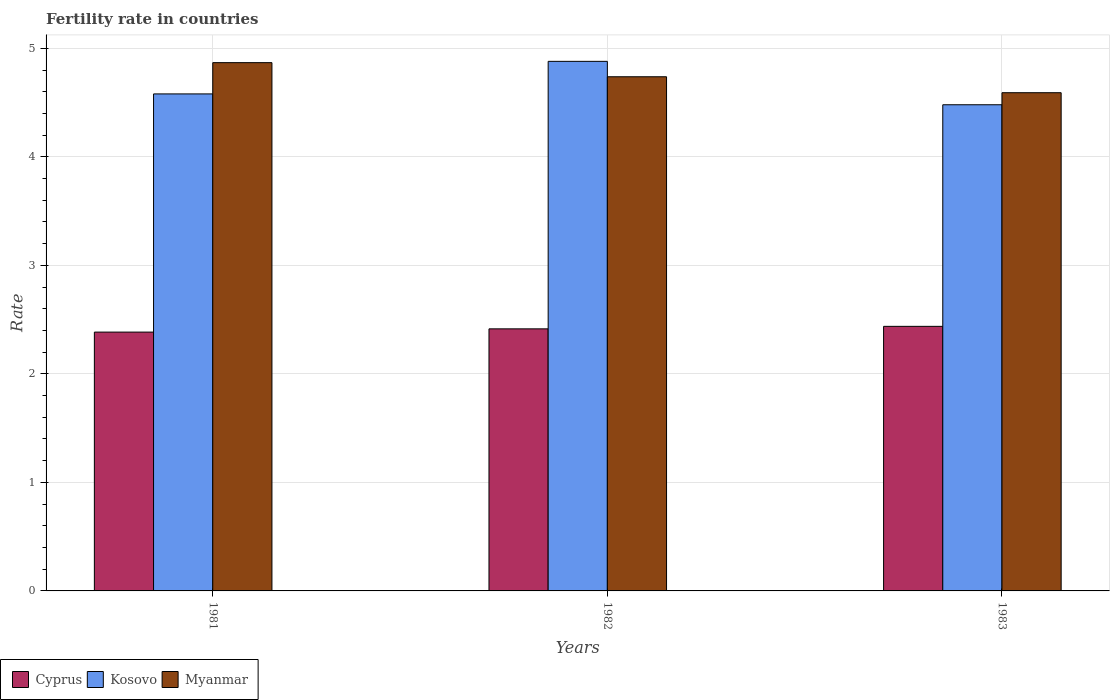How many groups of bars are there?
Offer a very short reply. 3. Are the number of bars per tick equal to the number of legend labels?
Make the answer very short. Yes. How many bars are there on the 2nd tick from the left?
Give a very brief answer. 3. What is the label of the 1st group of bars from the left?
Your answer should be compact. 1981. In how many cases, is the number of bars for a given year not equal to the number of legend labels?
Give a very brief answer. 0. What is the fertility rate in Myanmar in 1983?
Provide a short and direct response. 4.59. Across all years, what is the maximum fertility rate in Myanmar?
Keep it short and to the point. 4.87. Across all years, what is the minimum fertility rate in Myanmar?
Make the answer very short. 4.59. In which year was the fertility rate in Myanmar maximum?
Offer a very short reply. 1981. In which year was the fertility rate in Myanmar minimum?
Give a very brief answer. 1983. What is the total fertility rate in Cyprus in the graph?
Your response must be concise. 7.24. What is the difference between the fertility rate in Kosovo in 1981 and that in 1982?
Your response must be concise. -0.3. What is the difference between the fertility rate in Kosovo in 1981 and the fertility rate in Myanmar in 1982?
Your answer should be compact. -0.16. What is the average fertility rate in Kosovo per year?
Give a very brief answer. 4.65. In the year 1982, what is the difference between the fertility rate in Kosovo and fertility rate in Myanmar?
Make the answer very short. 0.14. In how many years, is the fertility rate in Myanmar greater than 1.2?
Your answer should be very brief. 3. What is the ratio of the fertility rate in Cyprus in 1981 to that in 1983?
Ensure brevity in your answer.  0.98. Is the fertility rate in Myanmar in 1981 less than that in 1983?
Provide a succinct answer. No. Is the difference between the fertility rate in Kosovo in 1981 and 1983 greater than the difference between the fertility rate in Myanmar in 1981 and 1983?
Your answer should be compact. No. What is the difference between the highest and the second highest fertility rate in Myanmar?
Provide a short and direct response. 0.13. What is the difference between the highest and the lowest fertility rate in Kosovo?
Offer a very short reply. 0.4. Is the sum of the fertility rate in Kosovo in 1982 and 1983 greater than the maximum fertility rate in Cyprus across all years?
Give a very brief answer. Yes. What does the 3rd bar from the left in 1982 represents?
Your response must be concise. Myanmar. What does the 3rd bar from the right in 1981 represents?
Keep it short and to the point. Cyprus. Is it the case that in every year, the sum of the fertility rate in Myanmar and fertility rate in Kosovo is greater than the fertility rate in Cyprus?
Ensure brevity in your answer.  Yes. How many bars are there?
Make the answer very short. 9. Are all the bars in the graph horizontal?
Your answer should be very brief. No. How many years are there in the graph?
Provide a succinct answer. 3. What is the difference between two consecutive major ticks on the Y-axis?
Offer a terse response. 1. Are the values on the major ticks of Y-axis written in scientific E-notation?
Give a very brief answer. No. Does the graph contain any zero values?
Offer a very short reply. No. How are the legend labels stacked?
Your response must be concise. Horizontal. What is the title of the graph?
Your answer should be compact. Fertility rate in countries. Does "Pacific island small states" appear as one of the legend labels in the graph?
Offer a very short reply. No. What is the label or title of the Y-axis?
Make the answer very short. Rate. What is the Rate in Cyprus in 1981?
Ensure brevity in your answer.  2.38. What is the Rate in Kosovo in 1981?
Offer a very short reply. 4.58. What is the Rate in Myanmar in 1981?
Your response must be concise. 4.87. What is the Rate of Cyprus in 1982?
Provide a succinct answer. 2.42. What is the Rate in Kosovo in 1982?
Keep it short and to the point. 4.88. What is the Rate of Myanmar in 1982?
Your response must be concise. 4.74. What is the Rate of Cyprus in 1983?
Provide a short and direct response. 2.44. What is the Rate of Kosovo in 1983?
Make the answer very short. 4.48. What is the Rate of Myanmar in 1983?
Your response must be concise. 4.59. Across all years, what is the maximum Rate of Cyprus?
Your response must be concise. 2.44. Across all years, what is the maximum Rate of Kosovo?
Make the answer very short. 4.88. Across all years, what is the maximum Rate in Myanmar?
Ensure brevity in your answer.  4.87. Across all years, what is the minimum Rate of Cyprus?
Your answer should be compact. 2.38. Across all years, what is the minimum Rate of Kosovo?
Your response must be concise. 4.48. Across all years, what is the minimum Rate of Myanmar?
Provide a succinct answer. 4.59. What is the total Rate in Cyprus in the graph?
Your answer should be very brief. 7.24. What is the total Rate of Kosovo in the graph?
Offer a terse response. 13.94. What is the total Rate in Myanmar in the graph?
Give a very brief answer. 14.2. What is the difference between the Rate in Cyprus in 1981 and that in 1982?
Your answer should be very brief. -0.03. What is the difference between the Rate in Kosovo in 1981 and that in 1982?
Your response must be concise. -0.3. What is the difference between the Rate of Myanmar in 1981 and that in 1982?
Provide a succinct answer. 0.13. What is the difference between the Rate of Cyprus in 1981 and that in 1983?
Offer a terse response. -0.05. What is the difference between the Rate of Kosovo in 1981 and that in 1983?
Provide a succinct answer. 0.1. What is the difference between the Rate of Myanmar in 1981 and that in 1983?
Your response must be concise. 0.28. What is the difference between the Rate of Cyprus in 1982 and that in 1983?
Make the answer very short. -0.02. What is the difference between the Rate of Kosovo in 1982 and that in 1983?
Make the answer very short. 0.4. What is the difference between the Rate of Myanmar in 1982 and that in 1983?
Your response must be concise. 0.15. What is the difference between the Rate of Cyprus in 1981 and the Rate of Kosovo in 1982?
Your response must be concise. -2.5. What is the difference between the Rate of Cyprus in 1981 and the Rate of Myanmar in 1982?
Make the answer very short. -2.35. What is the difference between the Rate of Kosovo in 1981 and the Rate of Myanmar in 1982?
Your response must be concise. -0.16. What is the difference between the Rate in Cyprus in 1981 and the Rate in Kosovo in 1983?
Your response must be concise. -2.1. What is the difference between the Rate in Cyprus in 1981 and the Rate in Myanmar in 1983?
Offer a very short reply. -2.21. What is the difference between the Rate of Kosovo in 1981 and the Rate of Myanmar in 1983?
Your response must be concise. -0.01. What is the difference between the Rate in Cyprus in 1982 and the Rate in Kosovo in 1983?
Keep it short and to the point. -2.06. What is the difference between the Rate of Cyprus in 1982 and the Rate of Myanmar in 1983?
Your answer should be compact. -2.18. What is the difference between the Rate in Kosovo in 1982 and the Rate in Myanmar in 1983?
Offer a very short reply. 0.29. What is the average Rate in Cyprus per year?
Provide a succinct answer. 2.41. What is the average Rate in Kosovo per year?
Make the answer very short. 4.65. What is the average Rate in Myanmar per year?
Offer a very short reply. 4.73. In the year 1981, what is the difference between the Rate of Cyprus and Rate of Kosovo?
Offer a very short reply. -2.19. In the year 1981, what is the difference between the Rate in Cyprus and Rate in Myanmar?
Your response must be concise. -2.48. In the year 1981, what is the difference between the Rate of Kosovo and Rate of Myanmar?
Offer a terse response. -0.29. In the year 1982, what is the difference between the Rate in Cyprus and Rate in Kosovo?
Ensure brevity in your answer.  -2.46. In the year 1982, what is the difference between the Rate of Cyprus and Rate of Myanmar?
Give a very brief answer. -2.32. In the year 1982, what is the difference between the Rate in Kosovo and Rate in Myanmar?
Offer a terse response. 0.14. In the year 1983, what is the difference between the Rate of Cyprus and Rate of Kosovo?
Offer a terse response. -2.04. In the year 1983, what is the difference between the Rate in Cyprus and Rate in Myanmar?
Give a very brief answer. -2.15. In the year 1983, what is the difference between the Rate in Kosovo and Rate in Myanmar?
Your answer should be very brief. -0.11. What is the ratio of the Rate in Cyprus in 1981 to that in 1982?
Your response must be concise. 0.99. What is the ratio of the Rate of Kosovo in 1981 to that in 1982?
Ensure brevity in your answer.  0.94. What is the ratio of the Rate in Myanmar in 1981 to that in 1982?
Ensure brevity in your answer.  1.03. What is the ratio of the Rate of Cyprus in 1981 to that in 1983?
Your response must be concise. 0.98. What is the ratio of the Rate in Kosovo in 1981 to that in 1983?
Ensure brevity in your answer.  1.02. What is the ratio of the Rate in Myanmar in 1981 to that in 1983?
Your response must be concise. 1.06. What is the ratio of the Rate of Cyprus in 1982 to that in 1983?
Provide a short and direct response. 0.99. What is the ratio of the Rate in Kosovo in 1982 to that in 1983?
Your answer should be very brief. 1.09. What is the ratio of the Rate of Myanmar in 1982 to that in 1983?
Your answer should be very brief. 1.03. What is the difference between the highest and the second highest Rate of Cyprus?
Provide a succinct answer. 0.02. What is the difference between the highest and the second highest Rate of Myanmar?
Keep it short and to the point. 0.13. What is the difference between the highest and the lowest Rate of Cyprus?
Offer a terse response. 0.05. What is the difference between the highest and the lowest Rate of Myanmar?
Ensure brevity in your answer.  0.28. 